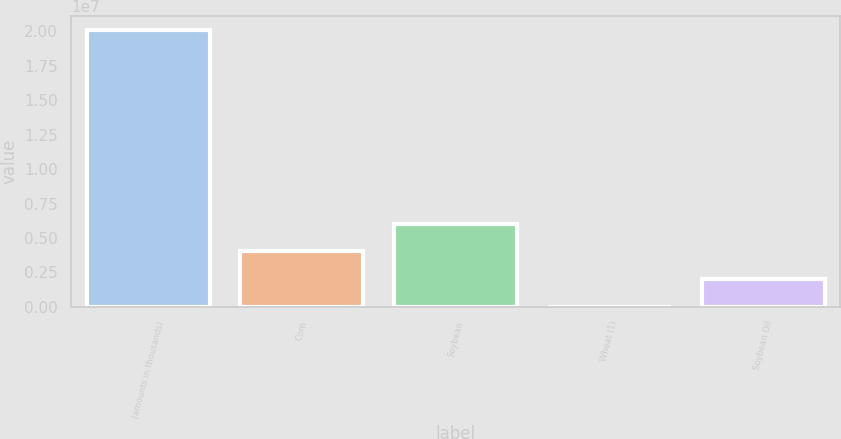Convert chart to OTSL. <chart><loc_0><loc_0><loc_500><loc_500><bar_chart><fcel>(amounts in thousands)<fcel>Corn<fcel>Soybean<fcel>Wheat (1)<fcel>Soybean Oil<nl><fcel>2.0112e+07<fcel>4.02241e+06<fcel>6.03361e+06<fcel>5<fcel>2.01121e+06<nl></chart> 